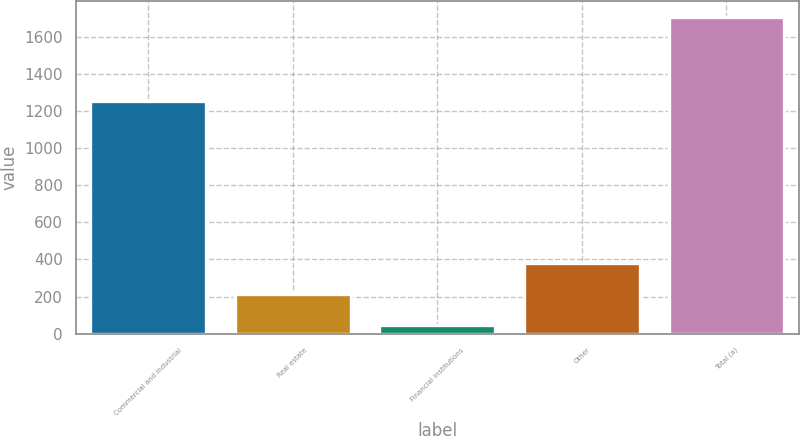<chart> <loc_0><loc_0><loc_500><loc_500><bar_chart><fcel>Commercial and industrial<fcel>Real estate<fcel>Financial institutions<fcel>Other<fcel>Total (a)<nl><fcel>1256<fcel>214.2<fcel>48<fcel>380.4<fcel>1710<nl></chart> 